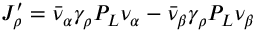<formula> <loc_0><loc_0><loc_500><loc_500>J _ { \rho } ^ { \prime } = \bar { \nu } _ { \alpha } \gamma _ { \rho } P _ { L } \nu _ { \alpha } - \bar { \nu } _ { \beta } \gamma _ { \rho } P _ { L } \nu _ { \beta }</formula> 